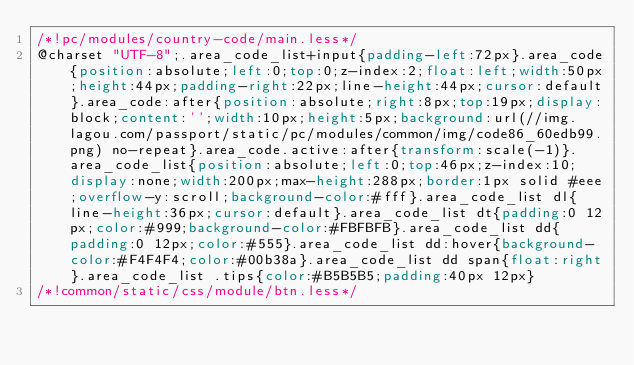Convert code to text. <code><loc_0><loc_0><loc_500><loc_500><_CSS_>/*!pc/modules/country-code/main.less*/
@charset "UTF-8";.area_code_list+input{padding-left:72px}.area_code{position:absolute;left:0;top:0;z-index:2;float:left;width:50px;height:44px;padding-right:22px;line-height:44px;cursor:default}.area_code:after{position:absolute;right:8px;top:19px;display:block;content:'';width:10px;height:5px;background:url(//img.lagou.com/passport/static/pc/modules/common/img/code86_60edb99.png) no-repeat}.area_code.active:after{transform:scale(-1)}.area_code_list{position:absolute;left:0;top:46px;z-index:10;display:none;width:200px;max-height:288px;border:1px solid #eee;overflow-y:scroll;background-color:#fff}.area_code_list dl{line-height:36px;cursor:default}.area_code_list dt{padding:0 12px;color:#999;background-color:#FBFBFB}.area_code_list dd{padding:0 12px;color:#555}.area_code_list dd:hover{background-color:#F4F4F4;color:#00b38a}.area_code_list dd span{float:right}.area_code_list .tips{color:#B5B5B5;padding:40px 12px}
/*!common/static/css/module/btn.less*/</code> 